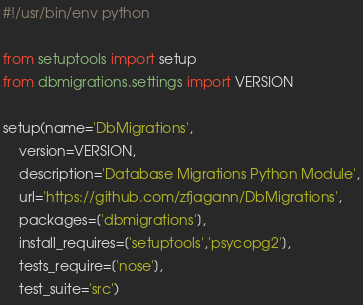<code> <loc_0><loc_0><loc_500><loc_500><_Python_>#!/usr/bin/env python

from setuptools import setup
from dbmigrations.settings import VERSION

setup(name='DbMigrations',
    version=VERSION,
    description='Database Migrations Python Module',
    url='https://github.com/zfjagann/DbMigrations',
    packages=['dbmigrations'],
    install_requires=['setuptools','psycopg2'],
    tests_require=['nose'],
    test_suite='src')
</code> 